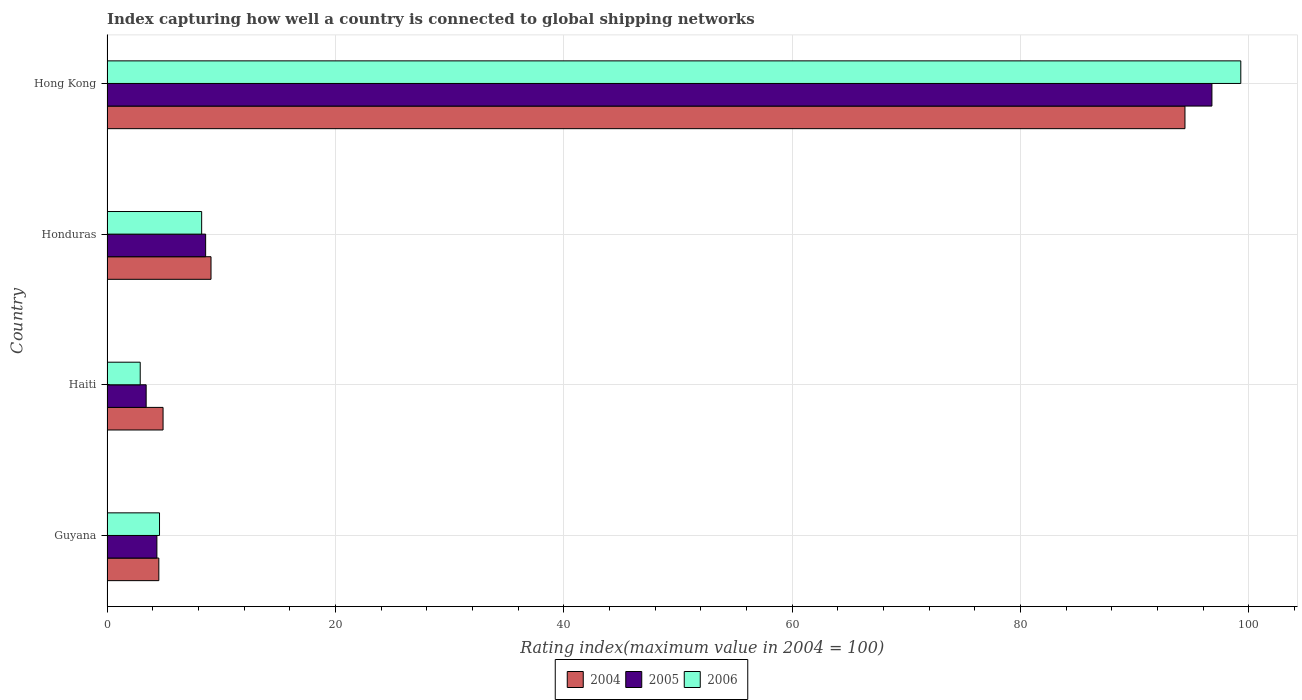How many groups of bars are there?
Keep it short and to the point. 4. Are the number of bars per tick equal to the number of legend labels?
Your answer should be compact. Yes. How many bars are there on the 1st tick from the bottom?
Provide a succinct answer. 3. What is the label of the 3rd group of bars from the top?
Your response must be concise. Haiti. What is the rating index in 2005 in Honduras?
Offer a terse response. 8.64. Across all countries, what is the maximum rating index in 2006?
Your response must be concise. 99.31. Across all countries, what is the minimum rating index in 2004?
Give a very brief answer. 4.54. In which country was the rating index in 2006 maximum?
Provide a succinct answer. Hong Kong. In which country was the rating index in 2006 minimum?
Keep it short and to the point. Haiti. What is the total rating index in 2005 in the graph?
Provide a short and direct response. 113.22. What is the difference between the rating index in 2005 in Guyana and that in Honduras?
Your answer should be very brief. -4.27. What is the difference between the rating index in 2006 in Honduras and the rating index in 2005 in Haiti?
Offer a very short reply. 4.86. What is the average rating index in 2006 per country?
Offer a terse response. 28.78. What is the difference between the rating index in 2004 and rating index in 2005 in Honduras?
Offer a very short reply. 0.47. What is the ratio of the rating index in 2004 in Guyana to that in Haiti?
Provide a succinct answer. 0.92. What is the difference between the highest and the second highest rating index in 2004?
Ensure brevity in your answer.  85.31. What is the difference between the highest and the lowest rating index in 2005?
Ensure brevity in your answer.  93.35. Is it the case that in every country, the sum of the rating index in 2005 and rating index in 2004 is greater than the rating index in 2006?
Keep it short and to the point. Yes. Are the values on the major ticks of X-axis written in scientific E-notation?
Your answer should be very brief. No. Does the graph contain grids?
Keep it short and to the point. Yes. How are the legend labels stacked?
Your answer should be compact. Horizontal. What is the title of the graph?
Provide a short and direct response. Index capturing how well a country is connected to global shipping networks. What is the label or title of the X-axis?
Ensure brevity in your answer.  Rating index(maximum value in 2004 = 100). What is the label or title of the Y-axis?
Give a very brief answer. Country. What is the Rating index(maximum value in 2004 = 100) of 2004 in Guyana?
Provide a succinct answer. 4.54. What is the Rating index(maximum value in 2004 = 100) in 2005 in Guyana?
Give a very brief answer. 4.37. What is the Rating index(maximum value in 2004 = 100) of 2004 in Haiti?
Provide a succinct answer. 4.91. What is the Rating index(maximum value in 2004 = 100) in 2005 in Haiti?
Provide a short and direct response. 3.43. What is the Rating index(maximum value in 2004 = 100) of 2006 in Haiti?
Make the answer very short. 2.91. What is the Rating index(maximum value in 2004 = 100) of 2004 in Honduras?
Your answer should be very brief. 9.11. What is the Rating index(maximum value in 2004 = 100) of 2005 in Honduras?
Offer a terse response. 8.64. What is the Rating index(maximum value in 2004 = 100) of 2006 in Honduras?
Offer a terse response. 8.29. What is the Rating index(maximum value in 2004 = 100) of 2004 in Hong Kong?
Make the answer very short. 94.42. What is the Rating index(maximum value in 2004 = 100) of 2005 in Hong Kong?
Keep it short and to the point. 96.78. What is the Rating index(maximum value in 2004 = 100) of 2006 in Hong Kong?
Make the answer very short. 99.31. Across all countries, what is the maximum Rating index(maximum value in 2004 = 100) in 2004?
Offer a terse response. 94.42. Across all countries, what is the maximum Rating index(maximum value in 2004 = 100) in 2005?
Ensure brevity in your answer.  96.78. Across all countries, what is the maximum Rating index(maximum value in 2004 = 100) of 2006?
Keep it short and to the point. 99.31. Across all countries, what is the minimum Rating index(maximum value in 2004 = 100) of 2004?
Your answer should be compact. 4.54. Across all countries, what is the minimum Rating index(maximum value in 2004 = 100) in 2005?
Offer a very short reply. 3.43. Across all countries, what is the minimum Rating index(maximum value in 2004 = 100) of 2006?
Your answer should be very brief. 2.91. What is the total Rating index(maximum value in 2004 = 100) of 2004 in the graph?
Your answer should be compact. 112.98. What is the total Rating index(maximum value in 2004 = 100) of 2005 in the graph?
Make the answer very short. 113.22. What is the total Rating index(maximum value in 2004 = 100) in 2006 in the graph?
Your answer should be compact. 115.11. What is the difference between the Rating index(maximum value in 2004 = 100) in 2004 in Guyana and that in Haiti?
Give a very brief answer. -0.37. What is the difference between the Rating index(maximum value in 2004 = 100) of 2005 in Guyana and that in Haiti?
Your answer should be very brief. 0.94. What is the difference between the Rating index(maximum value in 2004 = 100) of 2006 in Guyana and that in Haiti?
Offer a terse response. 1.69. What is the difference between the Rating index(maximum value in 2004 = 100) in 2004 in Guyana and that in Honduras?
Provide a succinct answer. -4.57. What is the difference between the Rating index(maximum value in 2004 = 100) of 2005 in Guyana and that in Honduras?
Keep it short and to the point. -4.27. What is the difference between the Rating index(maximum value in 2004 = 100) in 2006 in Guyana and that in Honduras?
Offer a terse response. -3.69. What is the difference between the Rating index(maximum value in 2004 = 100) in 2004 in Guyana and that in Hong Kong?
Your answer should be very brief. -89.88. What is the difference between the Rating index(maximum value in 2004 = 100) of 2005 in Guyana and that in Hong Kong?
Your answer should be compact. -92.41. What is the difference between the Rating index(maximum value in 2004 = 100) of 2006 in Guyana and that in Hong Kong?
Give a very brief answer. -94.71. What is the difference between the Rating index(maximum value in 2004 = 100) in 2005 in Haiti and that in Honduras?
Keep it short and to the point. -5.21. What is the difference between the Rating index(maximum value in 2004 = 100) in 2006 in Haiti and that in Honduras?
Offer a very short reply. -5.38. What is the difference between the Rating index(maximum value in 2004 = 100) in 2004 in Haiti and that in Hong Kong?
Your answer should be compact. -89.51. What is the difference between the Rating index(maximum value in 2004 = 100) of 2005 in Haiti and that in Hong Kong?
Your response must be concise. -93.35. What is the difference between the Rating index(maximum value in 2004 = 100) of 2006 in Haiti and that in Hong Kong?
Keep it short and to the point. -96.4. What is the difference between the Rating index(maximum value in 2004 = 100) of 2004 in Honduras and that in Hong Kong?
Keep it short and to the point. -85.31. What is the difference between the Rating index(maximum value in 2004 = 100) of 2005 in Honduras and that in Hong Kong?
Keep it short and to the point. -88.14. What is the difference between the Rating index(maximum value in 2004 = 100) of 2006 in Honduras and that in Hong Kong?
Your answer should be very brief. -91.02. What is the difference between the Rating index(maximum value in 2004 = 100) of 2004 in Guyana and the Rating index(maximum value in 2004 = 100) of 2005 in Haiti?
Offer a terse response. 1.11. What is the difference between the Rating index(maximum value in 2004 = 100) of 2004 in Guyana and the Rating index(maximum value in 2004 = 100) of 2006 in Haiti?
Offer a very short reply. 1.63. What is the difference between the Rating index(maximum value in 2004 = 100) in 2005 in Guyana and the Rating index(maximum value in 2004 = 100) in 2006 in Haiti?
Keep it short and to the point. 1.46. What is the difference between the Rating index(maximum value in 2004 = 100) in 2004 in Guyana and the Rating index(maximum value in 2004 = 100) in 2006 in Honduras?
Give a very brief answer. -3.75. What is the difference between the Rating index(maximum value in 2004 = 100) of 2005 in Guyana and the Rating index(maximum value in 2004 = 100) of 2006 in Honduras?
Your answer should be very brief. -3.92. What is the difference between the Rating index(maximum value in 2004 = 100) in 2004 in Guyana and the Rating index(maximum value in 2004 = 100) in 2005 in Hong Kong?
Offer a very short reply. -92.24. What is the difference between the Rating index(maximum value in 2004 = 100) of 2004 in Guyana and the Rating index(maximum value in 2004 = 100) of 2006 in Hong Kong?
Provide a short and direct response. -94.77. What is the difference between the Rating index(maximum value in 2004 = 100) in 2005 in Guyana and the Rating index(maximum value in 2004 = 100) in 2006 in Hong Kong?
Provide a short and direct response. -94.94. What is the difference between the Rating index(maximum value in 2004 = 100) of 2004 in Haiti and the Rating index(maximum value in 2004 = 100) of 2005 in Honduras?
Provide a succinct answer. -3.73. What is the difference between the Rating index(maximum value in 2004 = 100) in 2004 in Haiti and the Rating index(maximum value in 2004 = 100) in 2006 in Honduras?
Make the answer very short. -3.38. What is the difference between the Rating index(maximum value in 2004 = 100) of 2005 in Haiti and the Rating index(maximum value in 2004 = 100) of 2006 in Honduras?
Give a very brief answer. -4.86. What is the difference between the Rating index(maximum value in 2004 = 100) in 2004 in Haiti and the Rating index(maximum value in 2004 = 100) in 2005 in Hong Kong?
Your answer should be compact. -91.87. What is the difference between the Rating index(maximum value in 2004 = 100) of 2004 in Haiti and the Rating index(maximum value in 2004 = 100) of 2006 in Hong Kong?
Offer a terse response. -94.4. What is the difference between the Rating index(maximum value in 2004 = 100) in 2005 in Haiti and the Rating index(maximum value in 2004 = 100) in 2006 in Hong Kong?
Make the answer very short. -95.88. What is the difference between the Rating index(maximum value in 2004 = 100) of 2004 in Honduras and the Rating index(maximum value in 2004 = 100) of 2005 in Hong Kong?
Keep it short and to the point. -87.67. What is the difference between the Rating index(maximum value in 2004 = 100) of 2004 in Honduras and the Rating index(maximum value in 2004 = 100) of 2006 in Hong Kong?
Give a very brief answer. -90.2. What is the difference between the Rating index(maximum value in 2004 = 100) in 2005 in Honduras and the Rating index(maximum value in 2004 = 100) in 2006 in Hong Kong?
Give a very brief answer. -90.67. What is the average Rating index(maximum value in 2004 = 100) in 2004 per country?
Provide a succinct answer. 28.25. What is the average Rating index(maximum value in 2004 = 100) in 2005 per country?
Your response must be concise. 28.3. What is the average Rating index(maximum value in 2004 = 100) in 2006 per country?
Provide a short and direct response. 28.78. What is the difference between the Rating index(maximum value in 2004 = 100) of 2004 and Rating index(maximum value in 2004 = 100) of 2005 in Guyana?
Your answer should be very brief. 0.17. What is the difference between the Rating index(maximum value in 2004 = 100) of 2004 and Rating index(maximum value in 2004 = 100) of 2006 in Guyana?
Provide a short and direct response. -0.06. What is the difference between the Rating index(maximum value in 2004 = 100) in 2005 and Rating index(maximum value in 2004 = 100) in 2006 in Guyana?
Your response must be concise. -0.23. What is the difference between the Rating index(maximum value in 2004 = 100) of 2004 and Rating index(maximum value in 2004 = 100) of 2005 in Haiti?
Provide a short and direct response. 1.48. What is the difference between the Rating index(maximum value in 2004 = 100) in 2005 and Rating index(maximum value in 2004 = 100) in 2006 in Haiti?
Your answer should be very brief. 0.52. What is the difference between the Rating index(maximum value in 2004 = 100) of 2004 and Rating index(maximum value in 2004 = 100) of 2005 in Honduras?
Your answer should be compact. 0.47. What is the difference between the Rating index(maximum value in 2004 = 100) of 2004 and Rating index(maximum value in 2004 = 100) of 2006 in Honduras?
Offer a terse response. 0.82. What is the difference between the Rating index(maximum value in 2004 = 100) of 2005 and Rating index(maximum value in 2004 = 100) of 2006 in Honduras?
Your answer should be very brief. 0.35. What is the difference between the Rating index(maximum value in 2004 = 100) of 2004 and Rating index(maximum value in 2004 = 100) of 2005 in Hong Kong?
Provide a short and direct response. -2.36. What is the difference between the Rating index(maximum value in 2004 = 100) of 2004 and Rating index(maximum value in 2004 = 100) of 2006 in Hong Kong?
Keep it short and to the point. -4.89. What is the difference between the Rating index(maximum value in 2004 = 100) in 2005 and Rating index(maximum value in 2004 = 100) in 2006 in Hong Kong?
Ensure brevity in your answer.  -2.53. What is the ratio of the Rating index(maximum value in 2004 = 100) in 2004 in Guyana to that in Haiti?
Ensure brevity in your answer.  0.92. What is the ratio of the Rating index(maximum value in 2004 = 100) in 2005 in Guyana to that in Haiti?
Give a very brief answer. 1.27. What is the ratio of the Rating index(maximum value in 2004 = 100) in 2006 in Guyana to that in Haiti?
Offer a terse response. 1.58. What is the ratio of the Rating index(maximum value in 2004 = 100) of 2004 in Guyana to that in Honduras?
Make the answer very short. 0.5. What is the ratio of the Rating index(maximum value in 2004 = 100) in 2005 in Guyana to that in Honduras?
Keep it short and to the point. 0.51. What is the ratio of the Rating index(maximum value in 2004 = 100) of 2006 in Guyana to that in Honduras?
Provide a short and direct response. 0.55. What is the ratio of the Rating index(maximum value in 2004 = 100) in 2004 in Guyana to that in Hong Kong?
Offer a terse response. 0.05. What is the ratio of the Rating index(maximum value in 2004 = 100) in 2005 in Guyana to that in Hong Kong?
Offer a terse response. 0.05. What is the ratio of the Rating index(maximum value in 2004 = 100) in 2006 in Guyana to that in Hong Kong?
Provide a succinct answer. 0.05. What is the ratio of the Rating index(maximum value in 2004 = 100) of 2004 in Haiti to that in Honduras?
Give a very brief answer. 0.54. What is the ratio of the Rating index(maximum value in 2004 = 100) of 2005 in Haiti to that in Honduras?
Offer a very short reply. 0.4. What is the ratio of the Rating index(maximum value in 2004 = 100) of 2006 in Haiti to that in Honduras?
Your answer should be very brief. 0.35. What is the ratio of the Rating index(maximum value in 2004 = 100) of 2004 in Haiti to that in Hong Kong?
Ensure brevity in your answer.  0.05. What is the ratio of the Rating index(maximum value in 2004 = 100) in 2005 in Haiti to that in Hong Kong?
Keep it short and to the point. 0.04. What is the ratio of the Rating index(maximum value in 2004 = 100) of 2006 in Haiti to that in Hong Kong?
Your response must be concise. 0.03. What is the ratio of the Rating index(maximum value in 2004 = 100) of 2004 in Honduras to that in Hong Kong?
Provide a short and direct response. 0.1. What is the ratio of the Rating index(maximum value in 2004 = 100) of 2005 in Honduras to that in Hong Kong?
Make the answer very short. 0.09. What is the ratio of the Rating index(maximum value in 2004 = 100) in 2006 in Honduras to that in Hong Kong?
Offer a terse response. 0.08. What is the difference between the highest and the second highest Rating index(maximum value in 2004 = 100) in 2004?
Make the answer very short. 85.31. What is the difference between the highest and the second highest Rating index(maximum value in 2004 = 100) in 2005?
Your answer should be compact. 88.14. What is the difference between the highest and the second highest Rating index(maximum value in 2004 = 100) of 2006?
Offer a very short reply. 91.02. What is the difference between the highest and the lowest Rating index(maximum value in 2004 = 100) in 2004?
Your answer should be very brief. 89.88. What is the difference between the highest and the lowest Rating index(maximum value in 2004 = 100) in 2005?
Your answer should be compact. 93.35. What is the difference between the highest and the lowest Rating index(maximum value in 2004 = 100) of 2006?
Give a very brief answer. 96.4. 